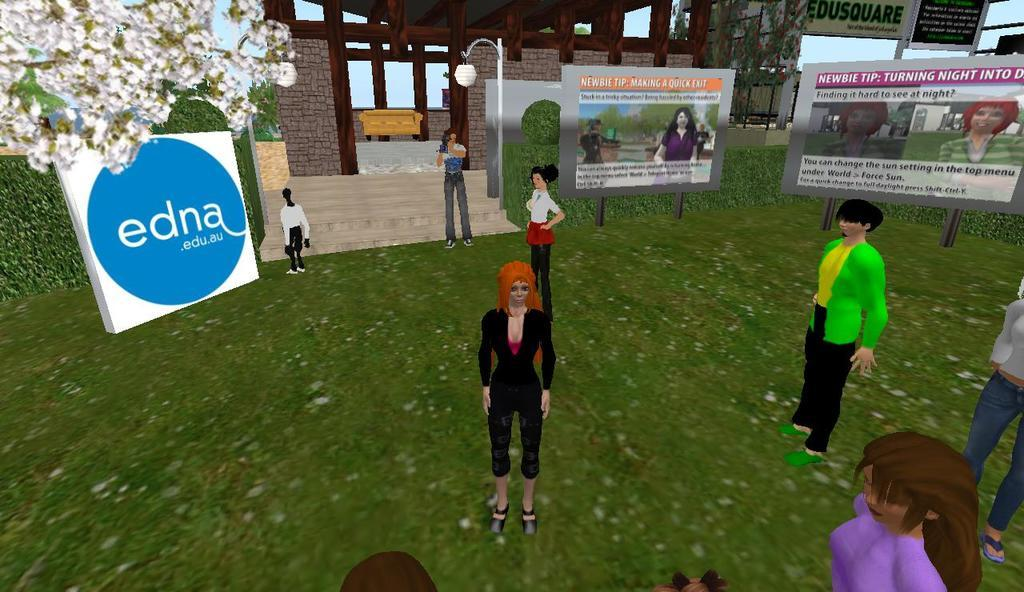Who or what can be seen in the image? There are people in the image. What type of natural environment is visible in the image? There are trees and grass in the image. What type of man-made structures are present in the image? There are buildings in the image. What are the boards with text and images used for? The boards with text and images are likely used for advertising or conveying information. What is the purpose of the light pole in the image? The light pole in the image provides illumination and may also serve as a support for signs or other objects. Can you see the face of the person combing their hair in the image? There is no person combing their hair in the image. What type of office furniture can be seen in the image? There is no office furniture present in the image. 